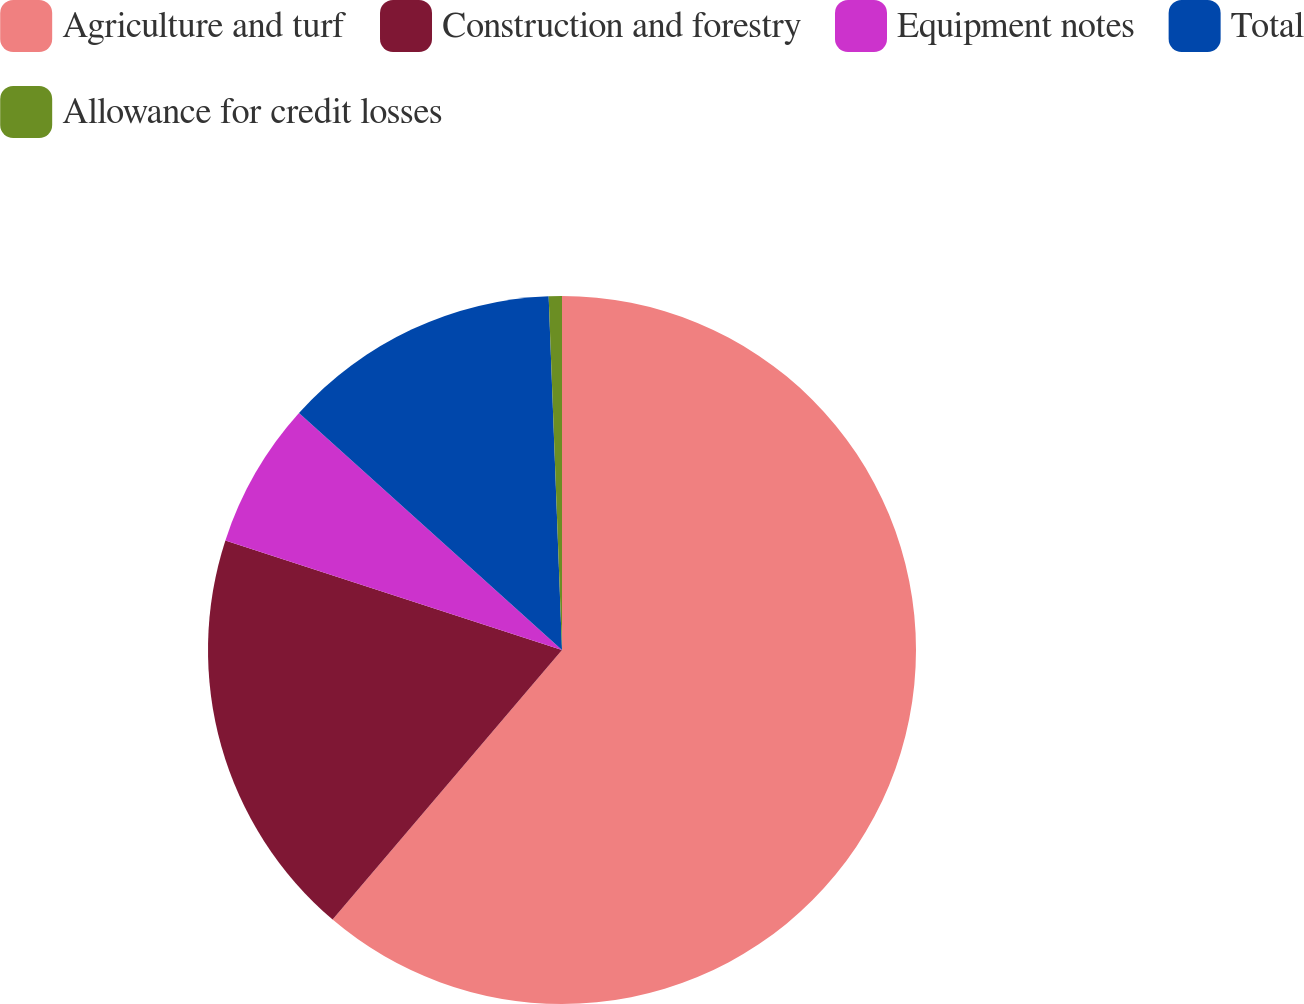<chart> <loc_0><loc_0><loc_500><loc_500><pie_chart><fcel>Agriculture and turf<fcel>Construction and forestry<fcel>Equipment notes<fcel>Total<fcel>Allowance for credit losses<nl><fcel>61.22%<fcel>18.79%<fcel>6.66%<fcel>12.73%<fcel>0.6%<nl></chart> 